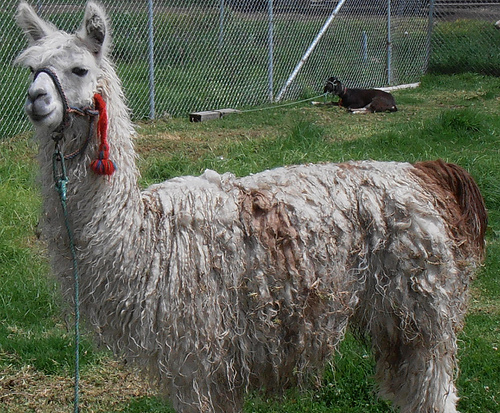<image>
Is there a llama under the goat? No. The llama is not positioned under the goat. The vertical relationship between these objects is different. 